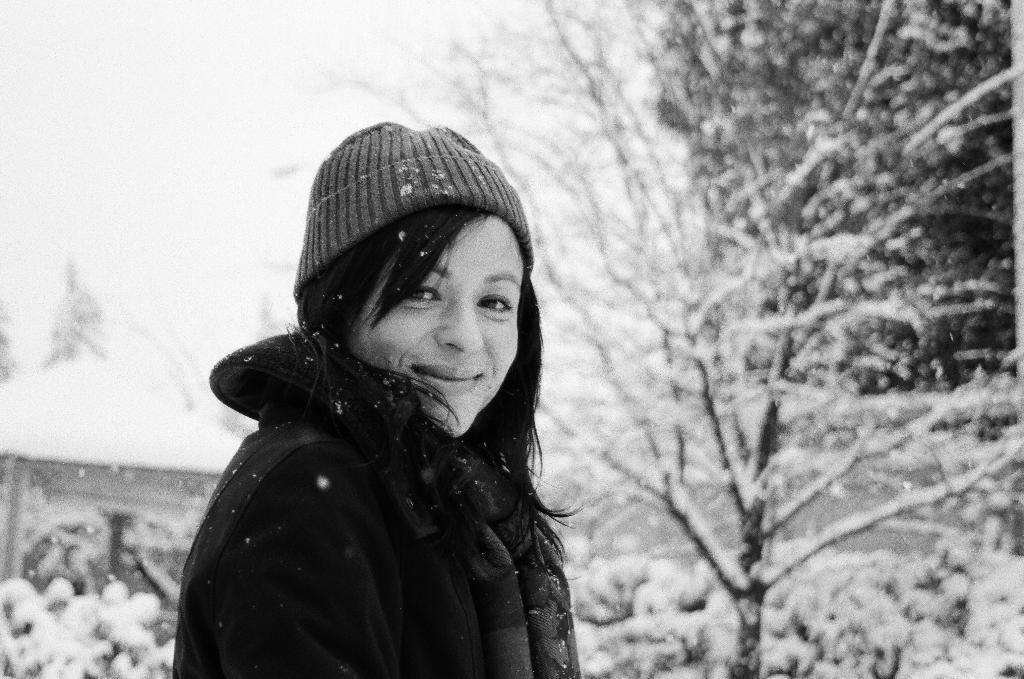In one or two sentences, can you explain what this image depicts? This is a black and white image. A person is standing wearing a woolen cap and jacket. There are trees behind her covered with the snow. 